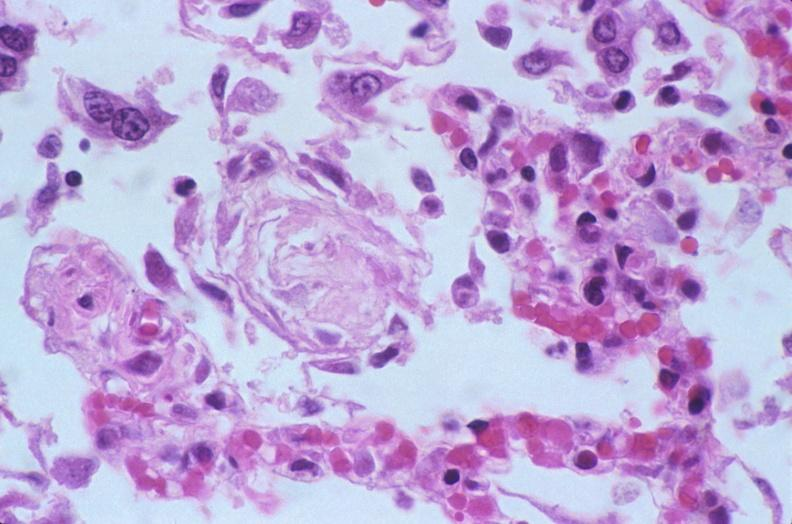s fallopian tube present?
Answer the question using a single word or phrase. No 